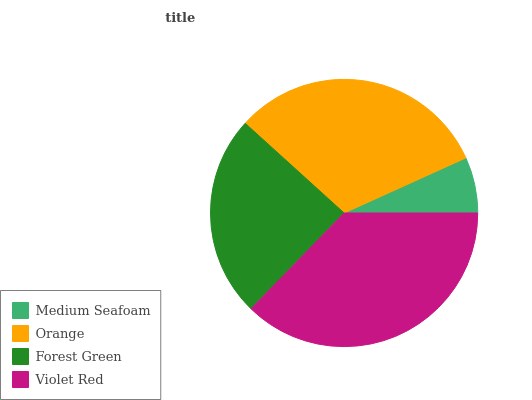Is Medium Seafoam the minimum?
Answer yes or no. Yes. Is Violet Red the maximum?
Answer yes or no. Yes. Is Orange the minimum?
Answer yes or no. No. Is Orange the maximum?
Answer yes or no. No. Is Orange greater than Medium Seafoam?
Answer yes or no. Yes. Is Medium Seafoam less than Orange?
Answer yes or no. Yes. Is Medium Seafoam greater than Orange?
Answer yes or no. No. Is Orange less than Medium Seafoam?
Answer yes or no. No. Is Orange the high median?
Answer yes or no. Yes. Is Forest Green the low median?
Answer yes or no. Yes. Is Forest Green the high median?
Answer yes or no. No. Is Violet Red the low median?
Answer yes or no. No. 